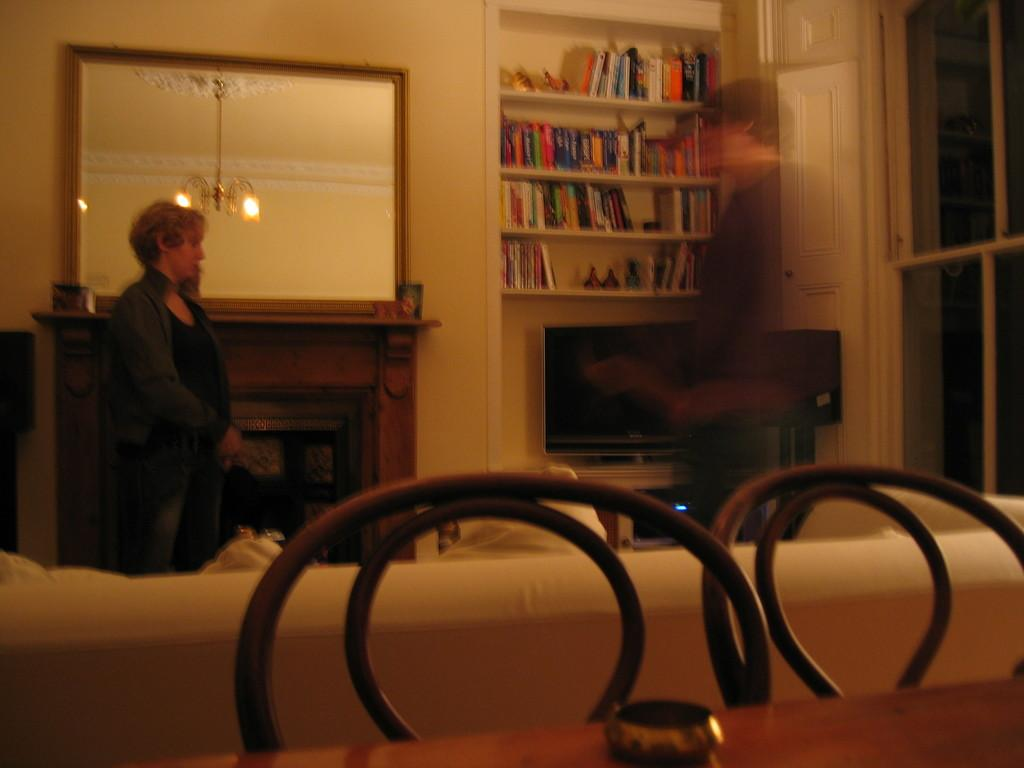What is the main subject of the image? There is a woman standing in the image. What object can be seen in the background of the image? There is a mirror in the image. What type of lighting fixture is present in the image? There is a chandelier in the image. What type of furniture is present in the image? There is a books rack in the image. What type of shoe is the woman wearing in the image? The image does not show the woman's shoes, so it cannot be determined what type of shoe she is wearing. 